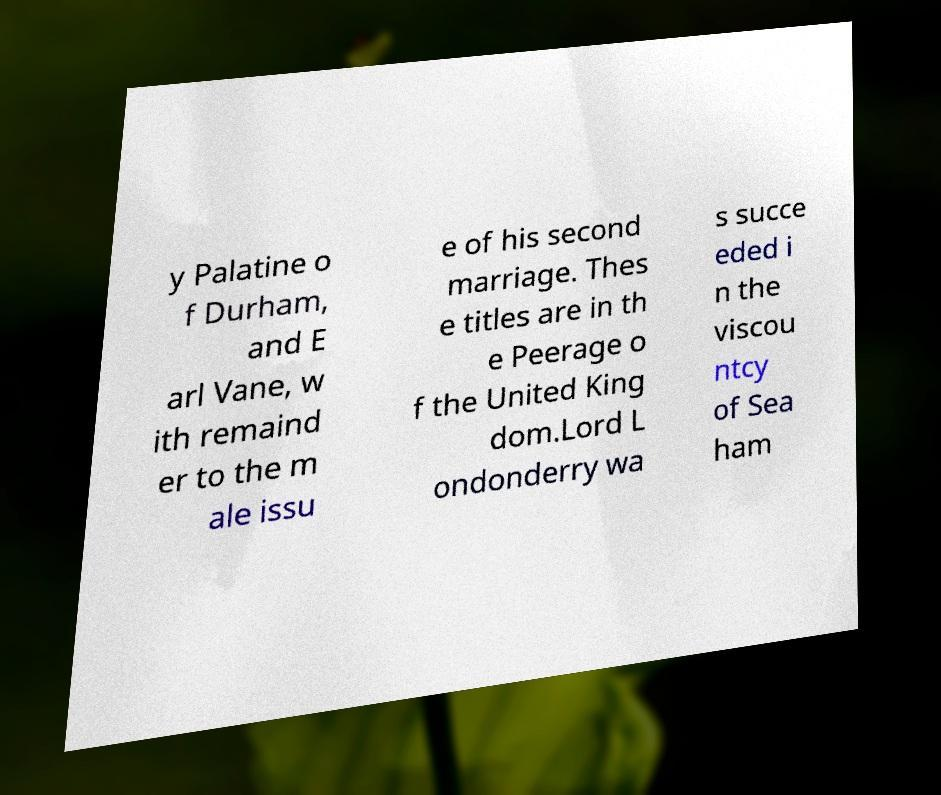I need the written content from this picture converted into text. Can you do that? y Palatine o f Durham, and E arl Vane, w ith remaind er to the m ale issu e of his second marriage. Thes e titles are in th e Peerage o f the United King dom.Lord L ondonderry wa s succe eded i n the viscou ntcy of Sea ham 